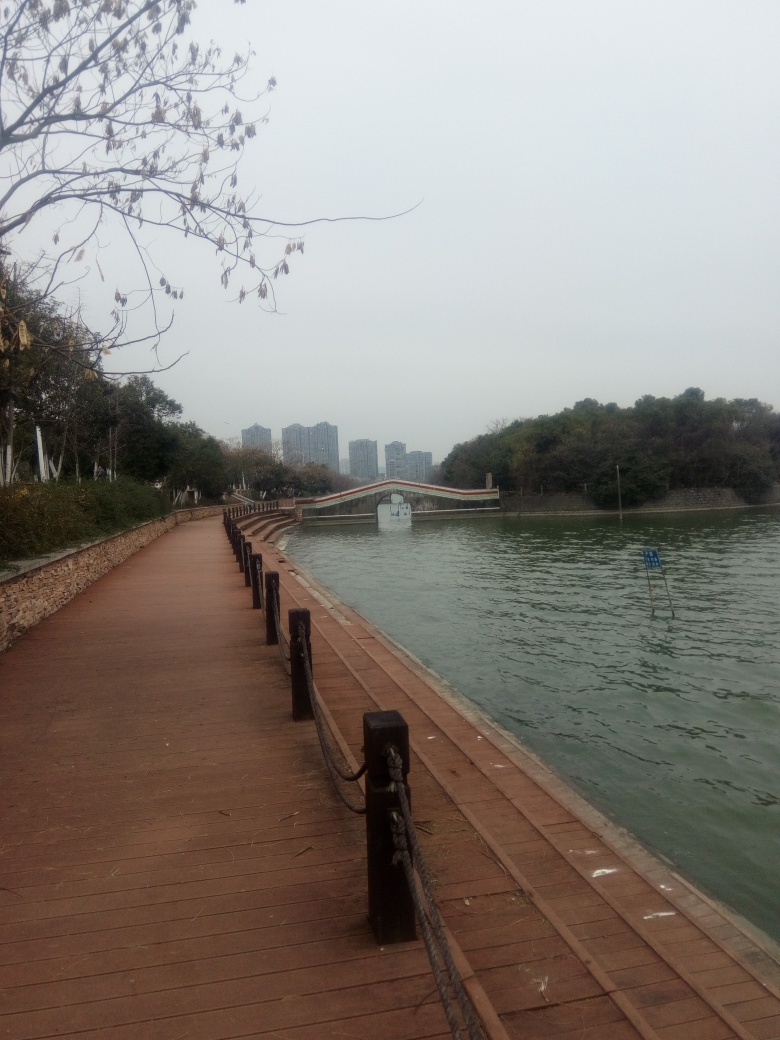What activities could this location be suitable for? The walkway along the water's edge makes for a perfect route for walking, jogging, or cycling. Its tranquil environment and scenic view also make it a great place for photography, casual strolls, or a relaxing sit by the lakeside. Additionally, the area could serve as a peaceful setting for picnicking on the grassy areas just off the path. Does this place look like it's frequently visited? Based on the image, the area looks well-maintained but not crowded, suggesting it might be visited regularly but not overrun with people. The absence of individuals in the image, however, makes it difficult to ascertain the exact frequency of visits. The infrastructure present, such as the well-kept footpath and barriers, indicates it's intended for public use and likely sees a consistent flow of visitors, perhaps more during favorable weather conditions. 